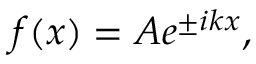<formula> <loc_0><loc_0><loc_500><loc_500>f ( x ) = A e ^ { \pm i k x } ,</formula> 